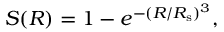<formula> <loc_0><loc_0><loc_500><loc_500>S ( R ) = 1 - e ^ { - ( R / R _ { s } ) ^ { 3 } } ,</formula> 